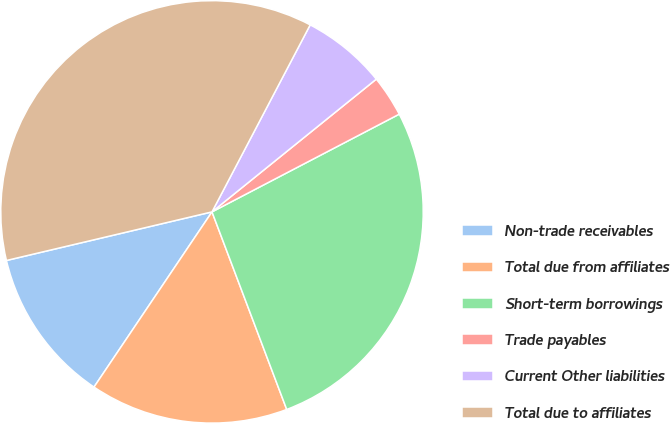<chart> <loc_0><loc_0><loc_500><loc_500><pie_chart><fcel>Non-trade receivables<fcel>Total due from affiliates<fcel>Short-term borrowings<fcel>Trade payables<fcel>Current Other liabilities<fcel>Total due to affiliates<nl><fcel>11.87%<fcel>15.19%<fcel>26.9%<fcel>3.16%<fcel>6.49%<fcel>36.39%<nl></chart> 